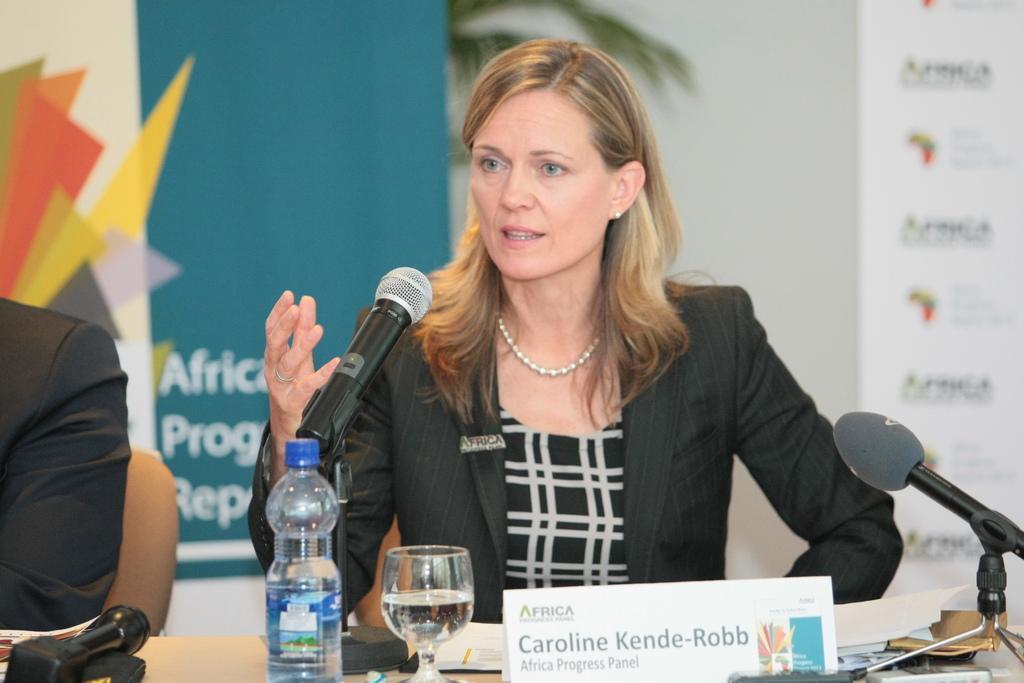How would you summarize this image in a sentence or two? In this picture we can see woman talking on mic and in front of her we can see bottle, glass, name board and beside to her we can see other man and in background we can see banner. 